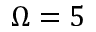<formula> <loc_0><loc_0><loc_500><loc_500>\Omega = 5</formula> 